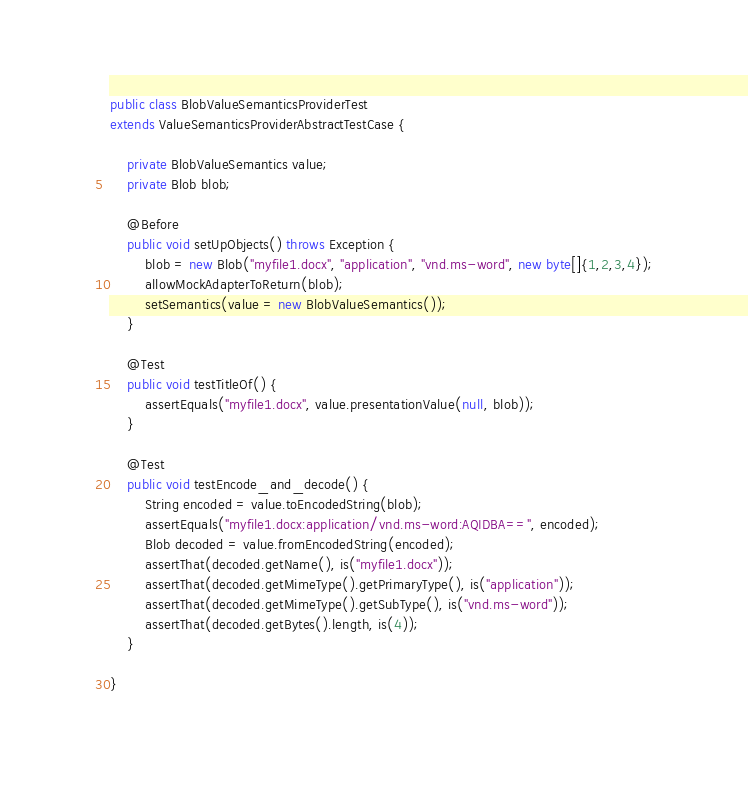<code> <loc_0><loc_0><loc_500><loc_500><_Java_>public class BlobValueSemanticsProviderTest
extends ValueSemanticsProviderAbstractTestCase {

    private BlobValueSemantics value;
    private Blob blob;

    @Before
    public void setUpObjects() throws Exception {
        blob = new Blob("myfile1.docx", "application", "vnd.ms-word", new byte[]{1,2,3,4});
        allowMockAdapterToReturn(blob);
        setSemantics(value = new BlobValueSemantics());
    }

    @Test
    public void testTitleOf() {
        assertEquals("myfile1.docx", value.presentationValue(null, blob));
    }

    @Test
    public void testEncode_and_decode() {
        String encoded = value.toEncodedString(blob);
        assertEquals("myfile1.docx:application/vnd.ms-word:AQIDBA==", encoded);
        Blob decoded = value.fromEncodedString(encoded);
        assertThat(decoded.getName(), is("myfile1.docx"));
        assertThat(decoded.getMimeType().getPrimaryType(), is("application"));
        assertThat(decoded.getMimeType().getSubType(), is("vnd.ms-word"));
        assertThat(decoded.getBytes().length, is(4));
    }

}
</code> 